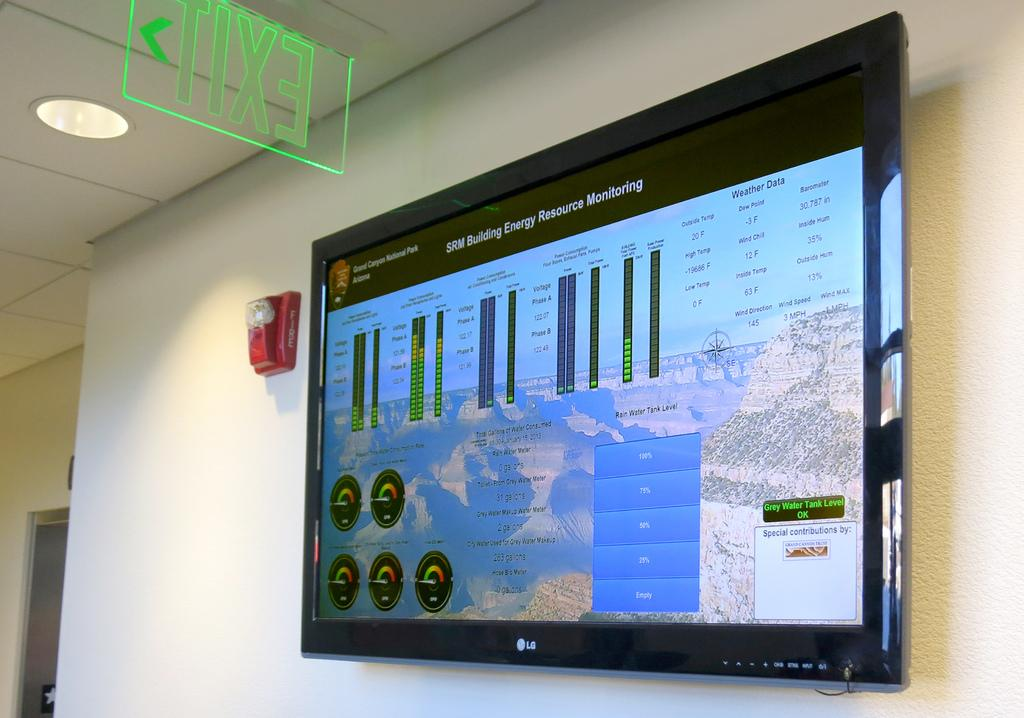<image>
Describe the image concisely. a monitor hangs on the wall showing information from the Grand Canyon National Park 